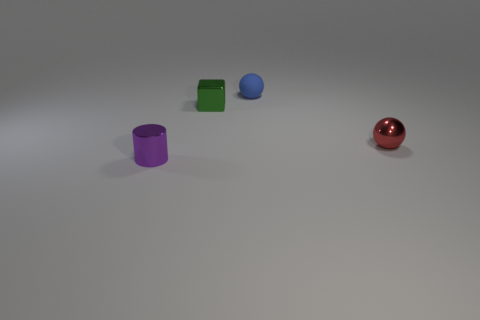The matte thing is what color?
Make the answer very short. Blue. There is another shiny thing that is the same shape as the blue object; what is its color?
Make the answer very short. Red. The tiny sphere that is made of the same material as the small purple object is what color?
Provide a short and direct response. Red. Is there a red thing that has the same material as the tiny cylinder?
Your answer should be very brief. Yes. What number of objects are green cylinders or shiny objects?
Give a very brief answer. 3. Is the material of the small red ball the same as the object behind the green metallic thing?
Provide a short and direct response. No. How big is the shiny thing that is right of the blue ball?
Your response must be concise. Small. Is the number of purple metallic things less than the number of big cyan rubber things?
Ensure brevity in your answer.  No. Is there another tiny sphere that has the same color as the metallic sphere?
Provide a succinct answer. No. There is a small metallic object that is left of the red shiny ball and in front of the green block; what is its shape?
Keep it short and to the point. Cylinder. 